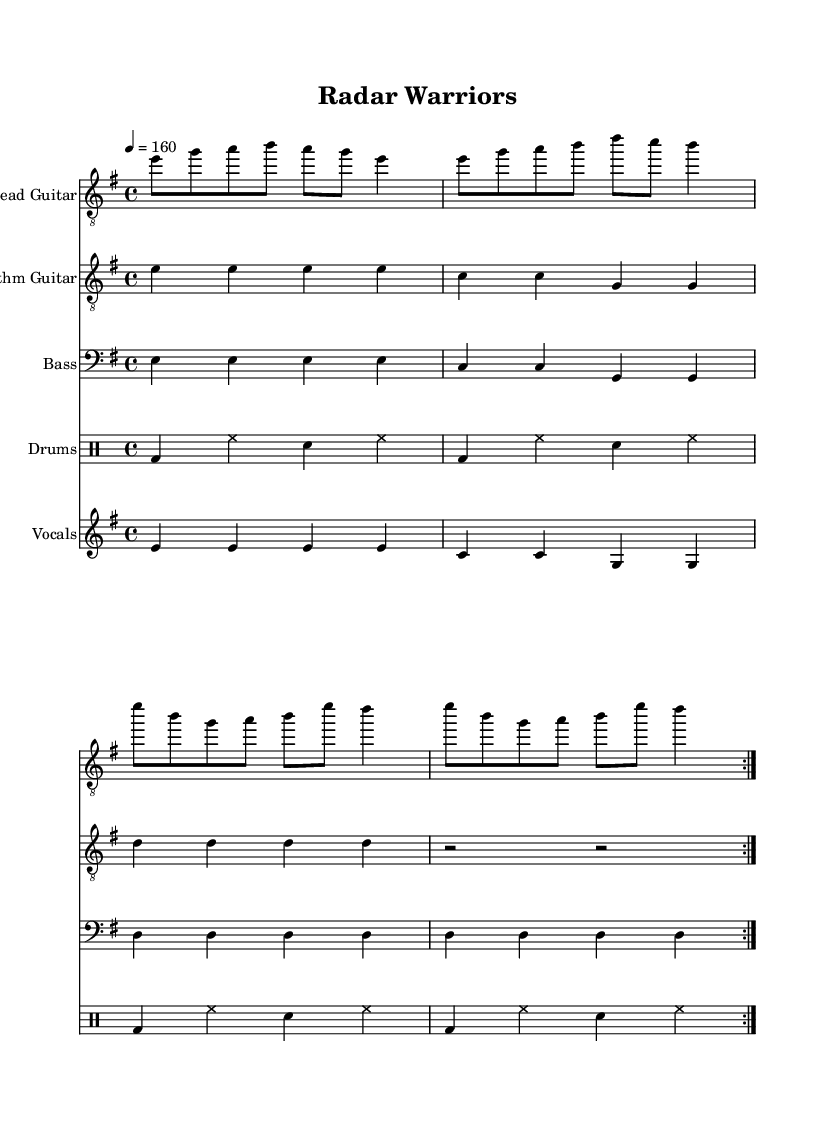What is the key signature of this music? The key signature is E minor, which has one sharp (F#) and indicates the tonal center and pitches used in the piece.
Answer: E minor What is the time signature of this music? The time signature shown is 4/4, meaning there are four beats per measure and the quarter note receives one beat.
Answer: 4/4 What is the tempo marking in this music? The tempo marking is 160 beats per minute, indicating a fast pace for the performance of the piece.
Answer: 160 How many measures are repeated in the rhythm guitar section? The rhythm guitar section includes a repeat sign indicating that the first section (four measures) should be played twice.
Answer: Two How many different instruments are being played in this score? The score features four distinct instrumental parts: lead guitar, rhythm guitar, bass, and drums, along with vocal accompaniment.
Answer: Four What lyrical theme is presented in the lyrics of this anthem? The lyrics describe the bravery and skill of air traffic controllers guiding planes, highlighting their heroic role in ensuring safe air travel during challenges.
Answer: Heroism In what section of the music do the drums participate? The drums are integrated into each measure of the score, emphasizing the rhythm and adding energy to the overall sound, showing strong coordination with the guitar elements.
Answer: In every measure 